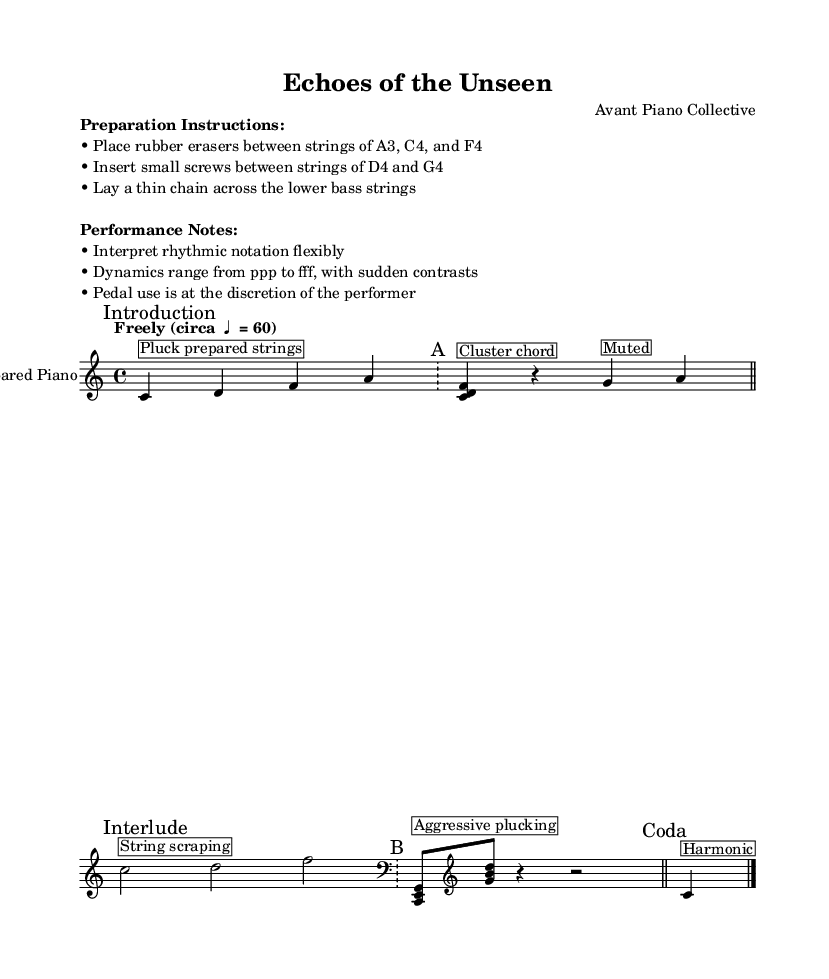What is the time signature of this music? The time signature is indicated at the beginning of the score, displaying 4/4, which means there are four beats in each measure.
Answer: 4/4 What is the tempo marking for this piece? The tempo marking is found in the global section, showing "Freely (circa ♩ = 60)," indicating a free pace around 60 beats per minute.
Answer: Freely (circa ♩ = 60) What is the instrument designated for this score? The instrument name is clearly stated in the score as "Prepared Piano," suggesting specific preparation of strings for performance.
Answer: Prepared Piano How many measures are in Section A? By counting the measures labeled "A," there are two measures in this section, evidenced by the endings marked with double bars.
Answer: 2 What performance instruction is given regarding dynamics? Among the performance notes, it is specified that dynamics should range from ppp to fff with sudden contrasts, guiding expressive interpretation.
Answer: ppp to fff What technique is employed in the Introduction? The introduction instructs to "Pluck prepared strings," indicating the use of an extended technique for sound production in this section.
Answer: Pluck prepared strings What unique action is suggested in the Interlude? The instruction for the interlude states "String scraping," indicating a particular technique applied on the prepared piano for specific sound effects.
Answer: String scraping 